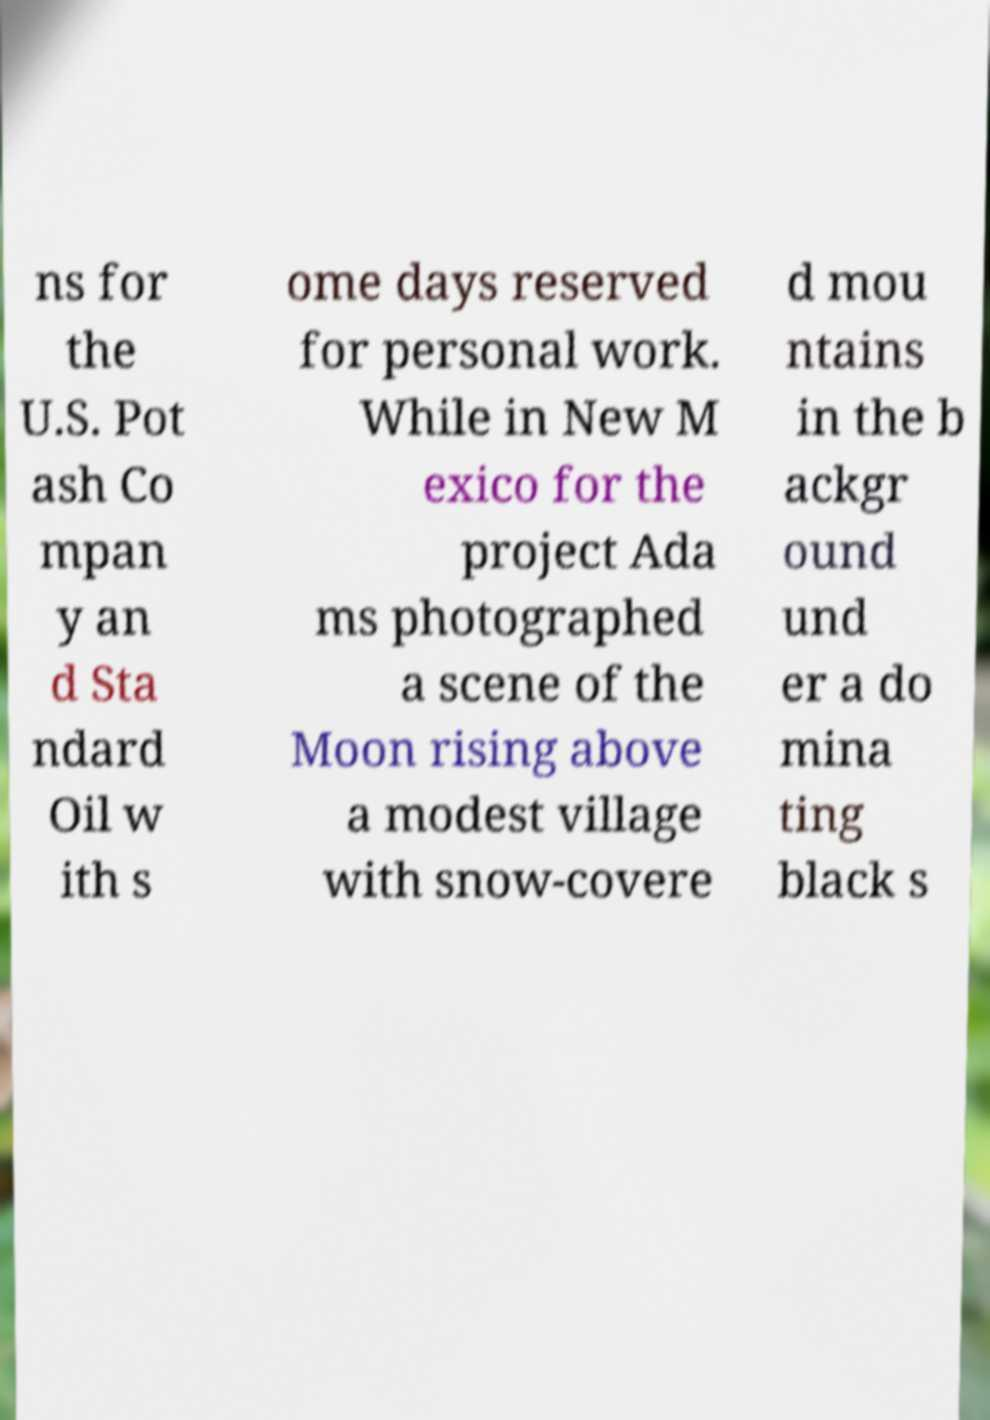For documentation purposes, I need the text within this image transcribed. Could you provide that? ns for the U.S. Pot ash Co mpan y an d Sta ndard Oil w ith s ome days reserved for personal work. While in New M exico for the project Ada ms photographed a scene of the Moon rising above a modest village with snow-covere d mou ntains in the b ackgr ound und er a do mina ting black s 